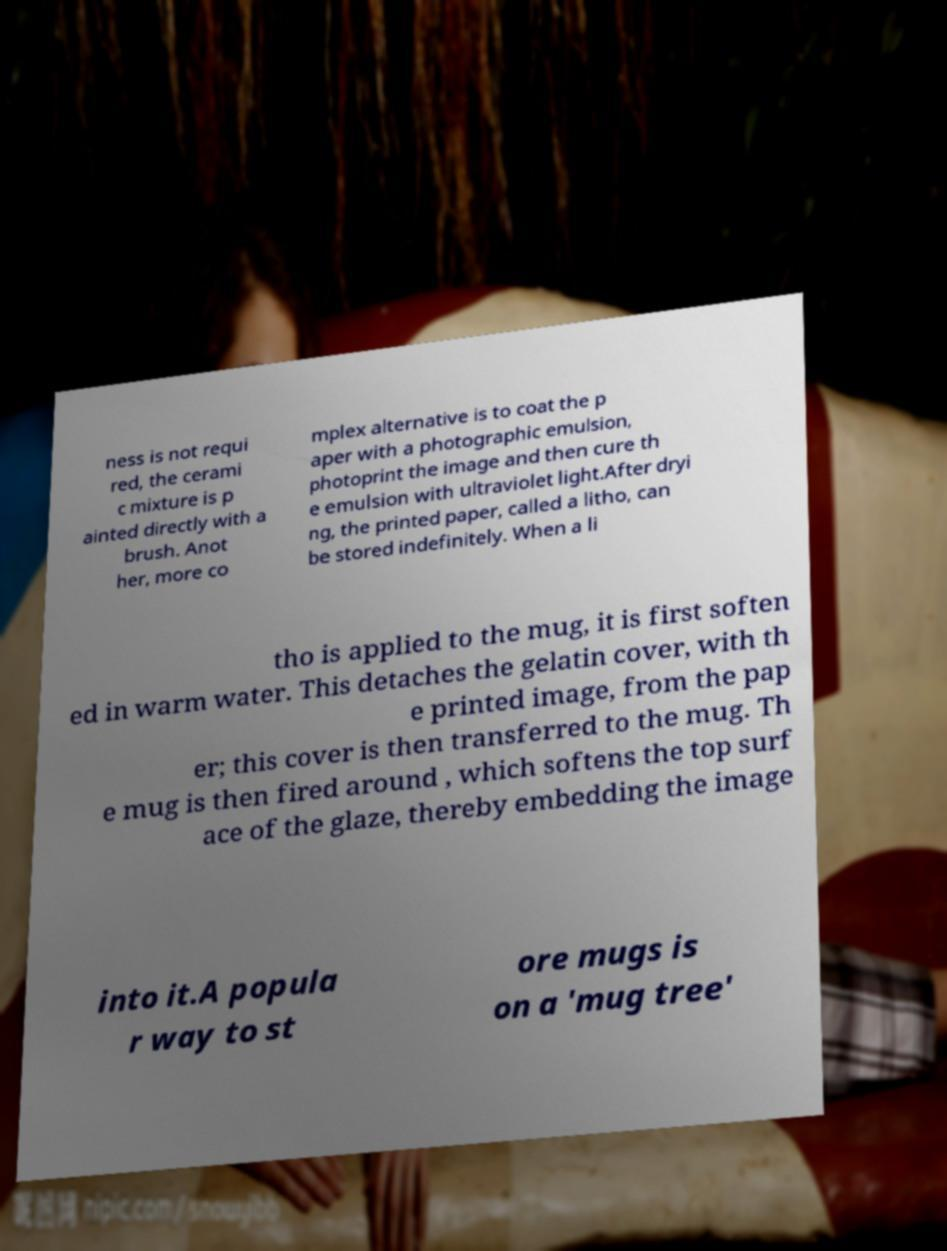Please read and relay the text visible in this image. What does it say? ness is not requi red, the cerami c mixture is p ainted directly with a brush. Anot her, more co mplex alternative is to coat the p aper with a photographic emulsion, photoprint the image and then cure th e emulsion with ultraviolet light.After dryi ng, the printed paper, called a litho, can be stored indefinitely. When a li tho is applied to the mug, it is first soften ed in warm water. This detaches the gelatin cover, with th e printed image, from the pap er; this cover is then transferred to the mug. Th e mug is then fired around , which softens the top surf ace of the glaze, thereby embedding the image into it.A popula r way to st ore mugs is on a 'mug tree' 